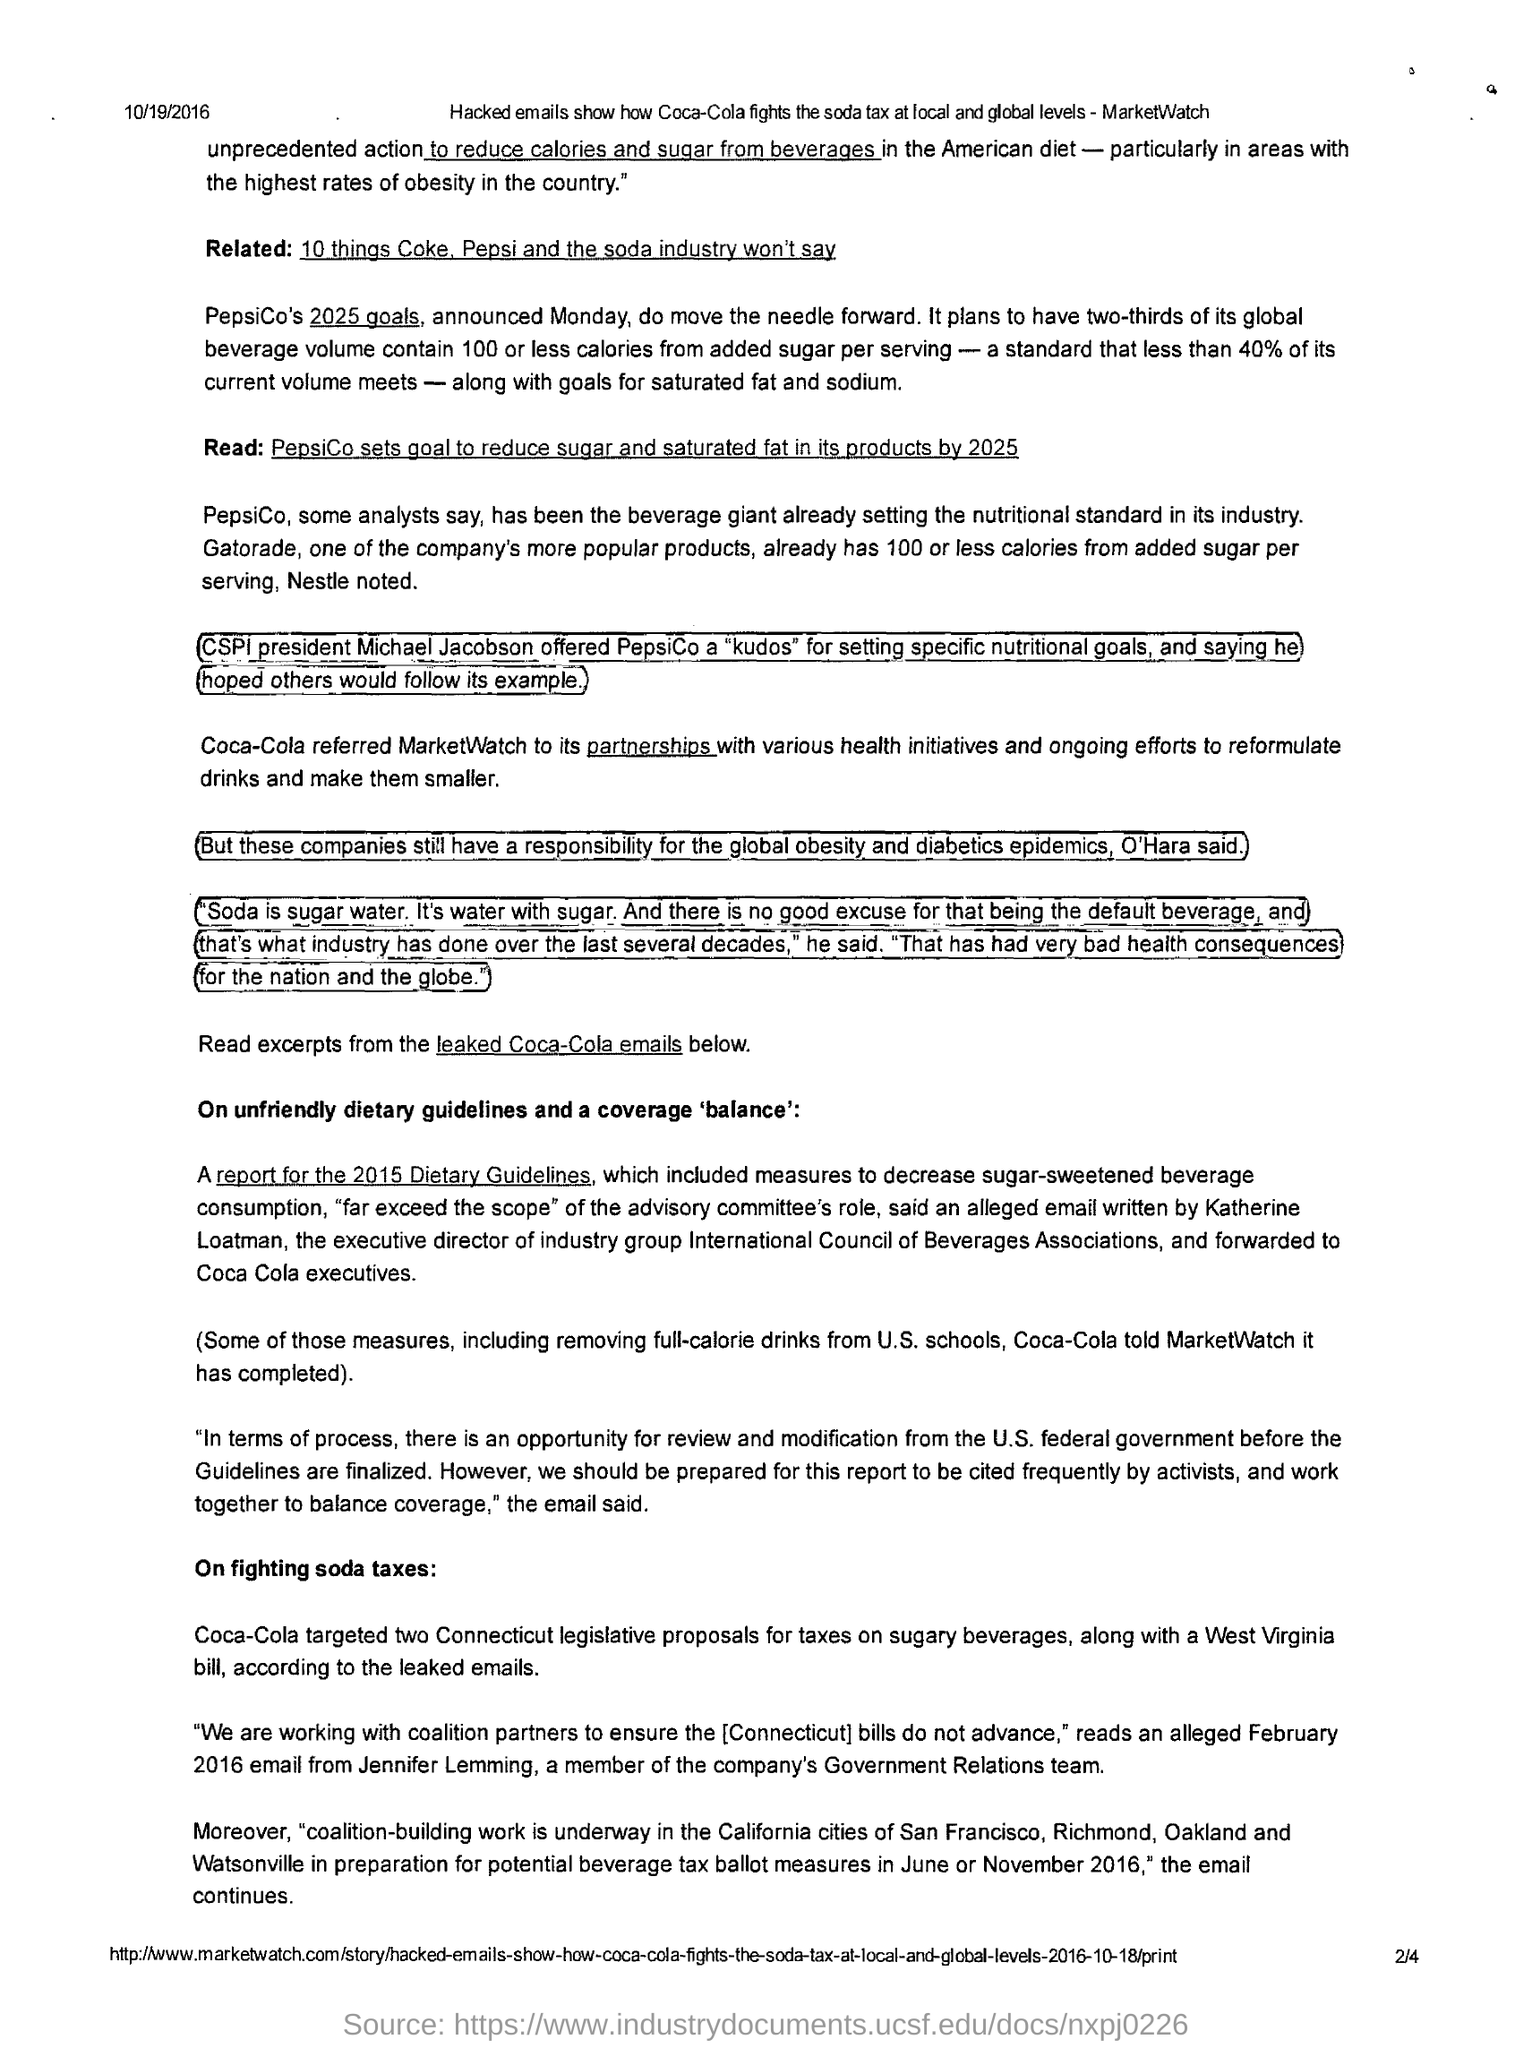Point out several critical features in this image. Coca-Cola targeted two Connecticut legislative proposals for taxes on beverages. The date mentioned in the header of the document is 10/19/2016. 